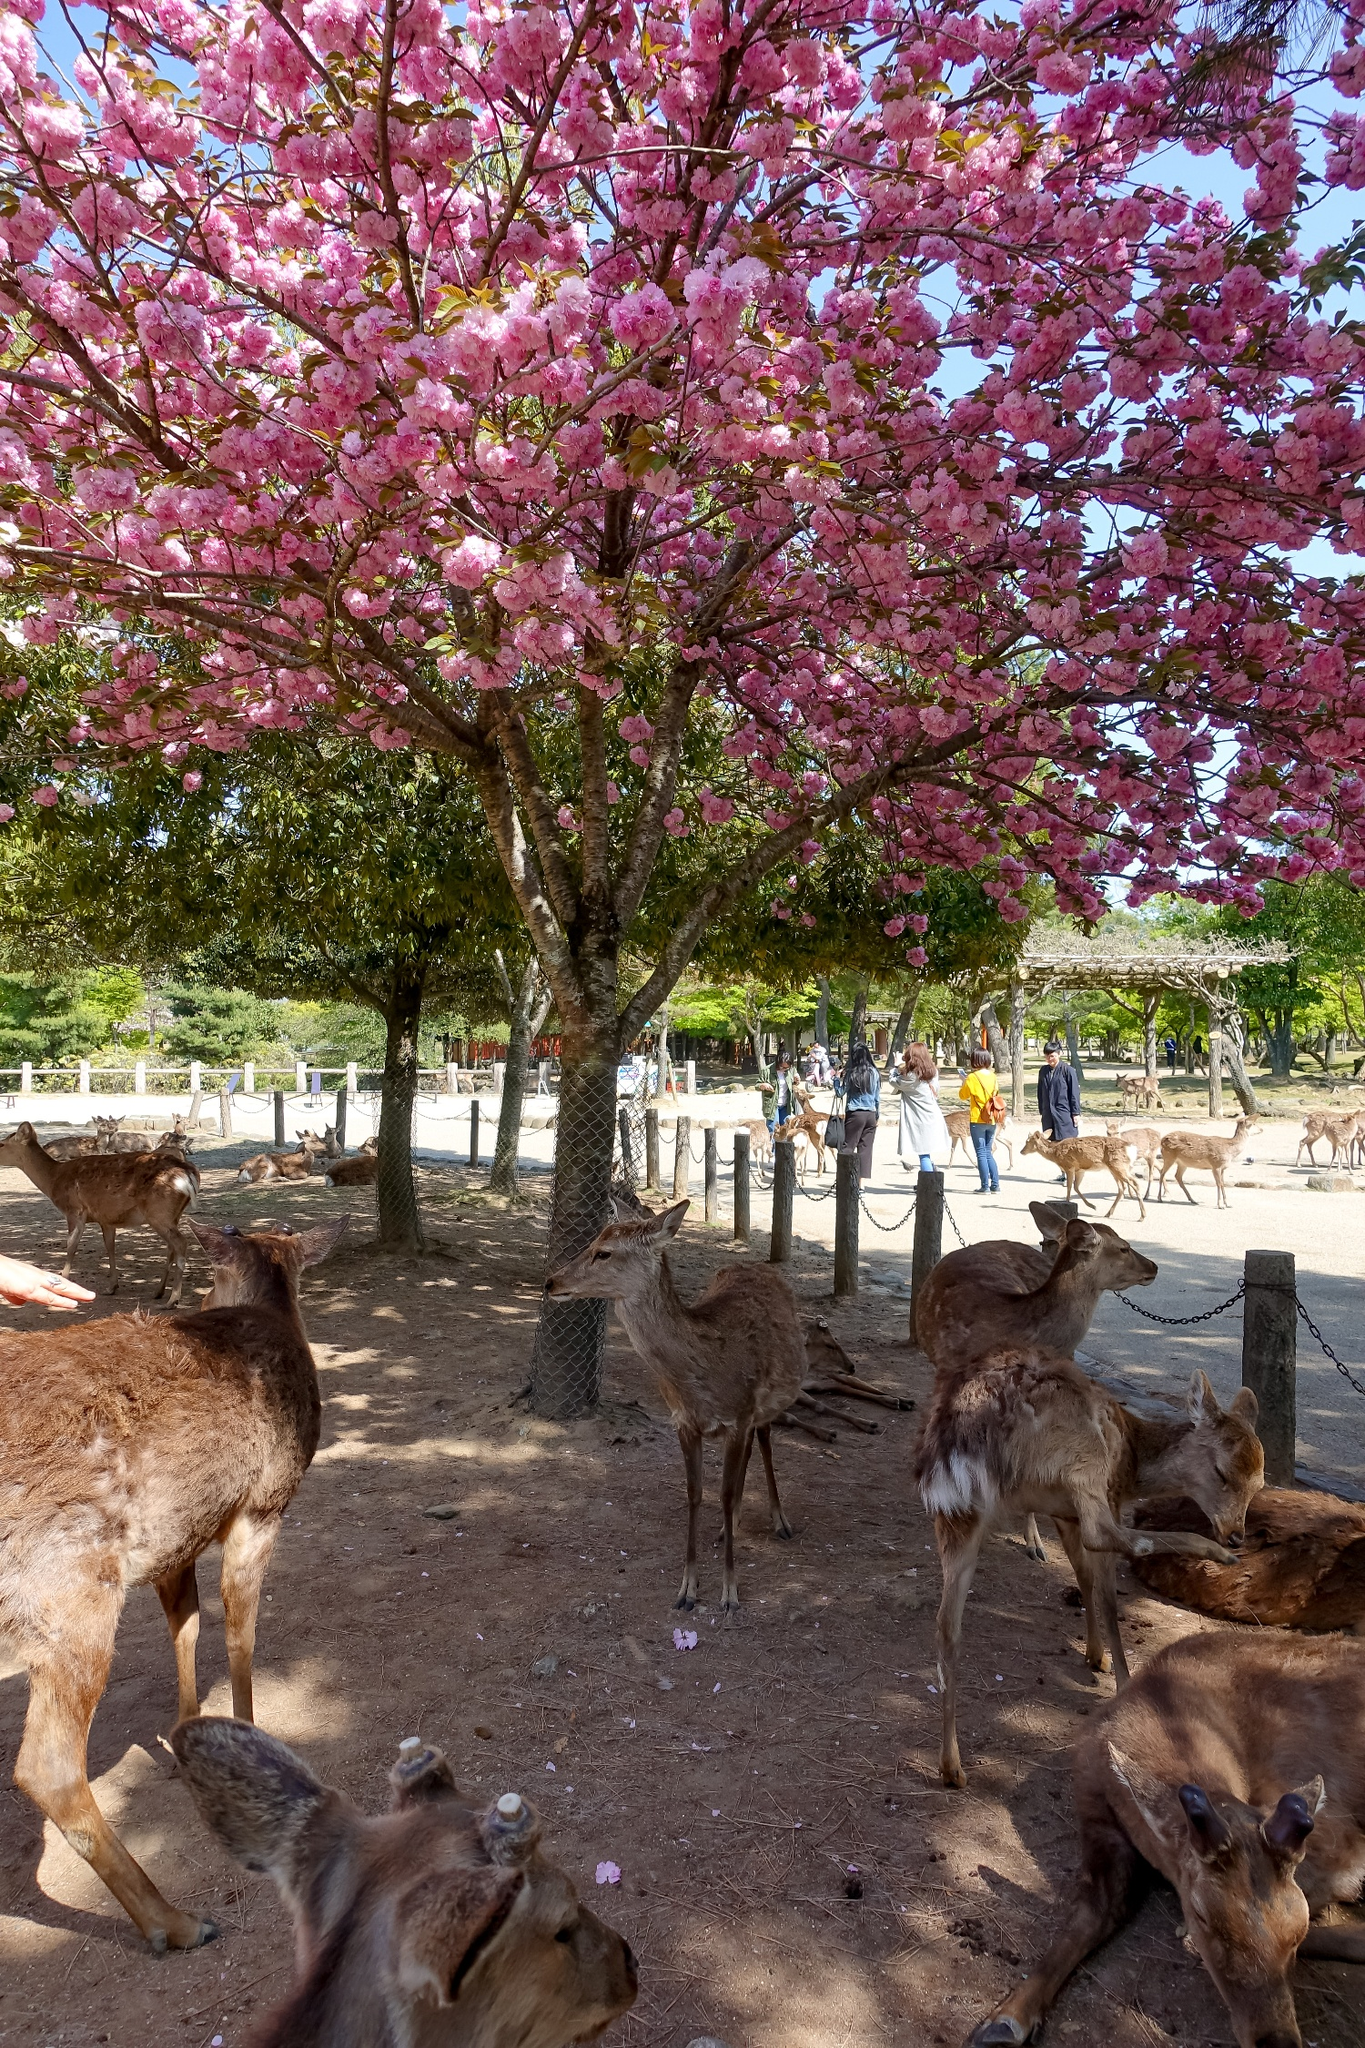Imagine if the deer could talk. What conversation do you think they would have under the cherry blossom tree? Imagine if the deer could talk! Under the cherry blossom tree, one deer might say, 'Isn't it wonderful how the blossoms look today? I feel so peaceful here.' Another could reply, 'Yes, the humans seem to enjoy the park as much as we do. Have you ever wondered what they're always so busy with?' A third deer might chime in, 'I heard from a bird that humans have things called 'jobs' that keep them occupied, but they come here to relax and enjoy nature, just like us!' The deer would likely reflect on the beauty of their surroundings, their quiet lives, and the curiosity they have about the bustling world of humans around them. Is there anything historically significant about cherry blossom trees in such settings? Cherry blossom trees, especially in parks, hold great historical and cultural significance, particularly in countries like Japan, where they symbolize the ephemeral nature of life. The practice of 'Hanami,' or cherry blossom viewing, has been a cherished tradition for centuries, dating back to the Nara period (710-794). During Hanami, people gather under cherry blossom trees to appreciate their fleeting beauty, celebrate renewal, and reflect on the transient nature of life. This tradition highlights the deep connection between natural beauty and the human spirit, making cherry blossom trees a timeless symbol of serenity and contemplation. Create a whimsical scenario involving the deer and the cherry blossom tree. In a whimsical twist of fate, the cherry blossom tree under which the deer rest is enchanted. One evening, as the sun sets, the tree wakes up and gently shakes its branches, causing a flurry of petals to fall like snow. Suddenly, the deer begin to glow with a soft light. 'Welcome, my deer friends,' the tree rumbles in a deep, gentle voice. 'Tonight, we embark on an adventure!' The deer, enchanted, suddenly gain the ability to talk and fly! Flying deer and the cherry blossom tree soar into the night sky, exploring magical lands filled with glowing flowers, talking animals, and rivers of stardust. They return at dawn, with the enchantment fading as the first light of day touches the park, leaving them with memories of a night unlike any other. 